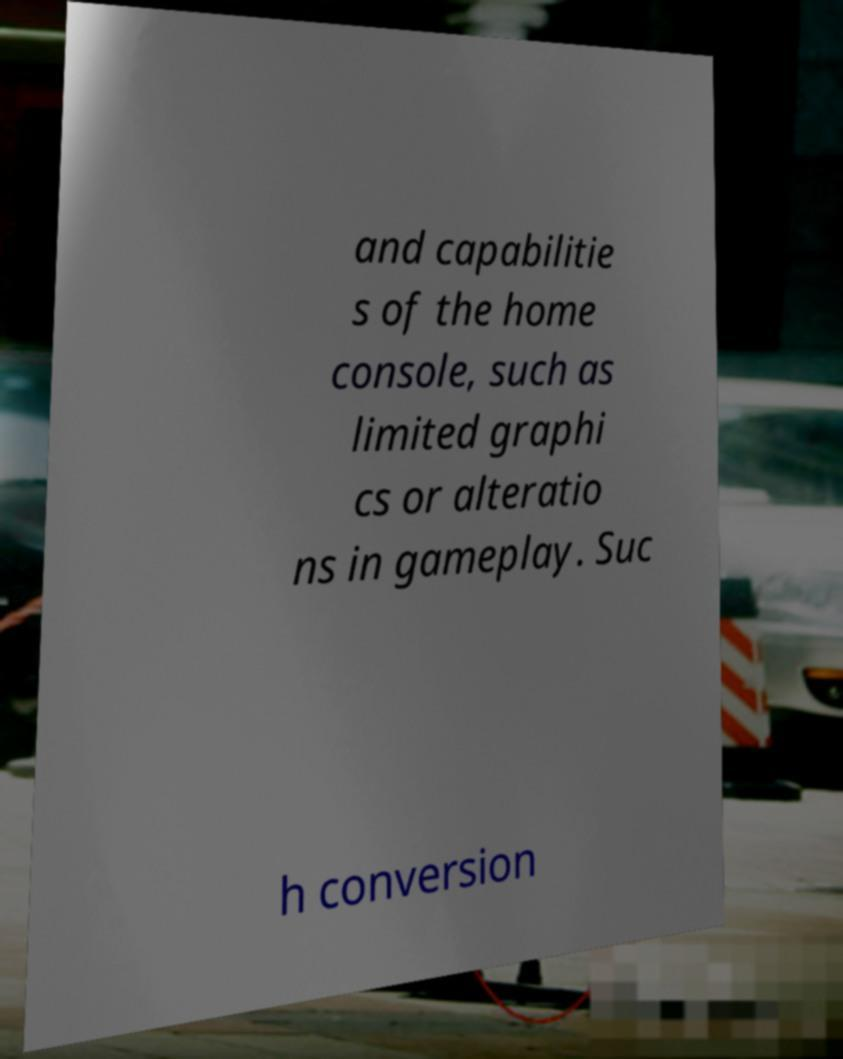For documentation purposes, I need the text within this image transcribed. Could you provide that? and capabilitie s of the home console, such as limited graphi cs or alteratio ns in gameplay. Suc h conversion 